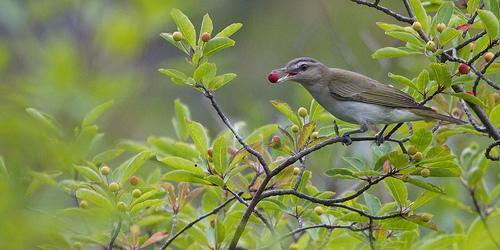How many birds are there?
Give a very brief answer. 1. 